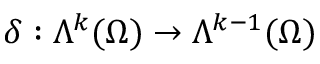<formula> <loc_0><loc_0><loc_500><loc_500>\delta \colon \Lambda ^ { k } ( \Omega ) \to \Lambda ^ { k - 1 } ( \Omega )</formula> 